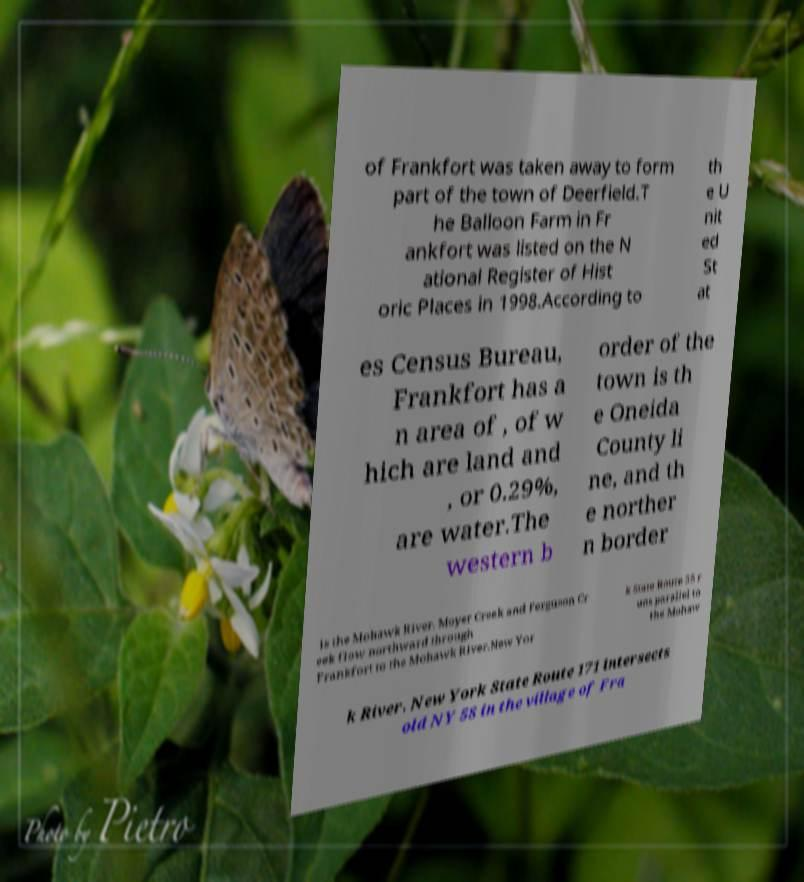Please identify and transcribe the text found in this image. of Frankfort was taken away to form part of the town of Deerfield.T he Balloon Farm in Fr ankfort was listed on the N ational Register of Hist oric Places in 1998.According to th e U nit ed St at es Census Bureau, Frankfort has a n area of , of w hich are land and , or 0.29%, are water.The western b order of the town is th e Oneida County li ne, and th e norther n border is the Mohawk River. Moyer Creek and Ferguson Cr eek flow northward through Frankfort to the Mohawk River.New Yor k State Route 5S r uns parallel to the Mohaw k River. New York State Route 171 intersects old NY 5S in the village of Fra 